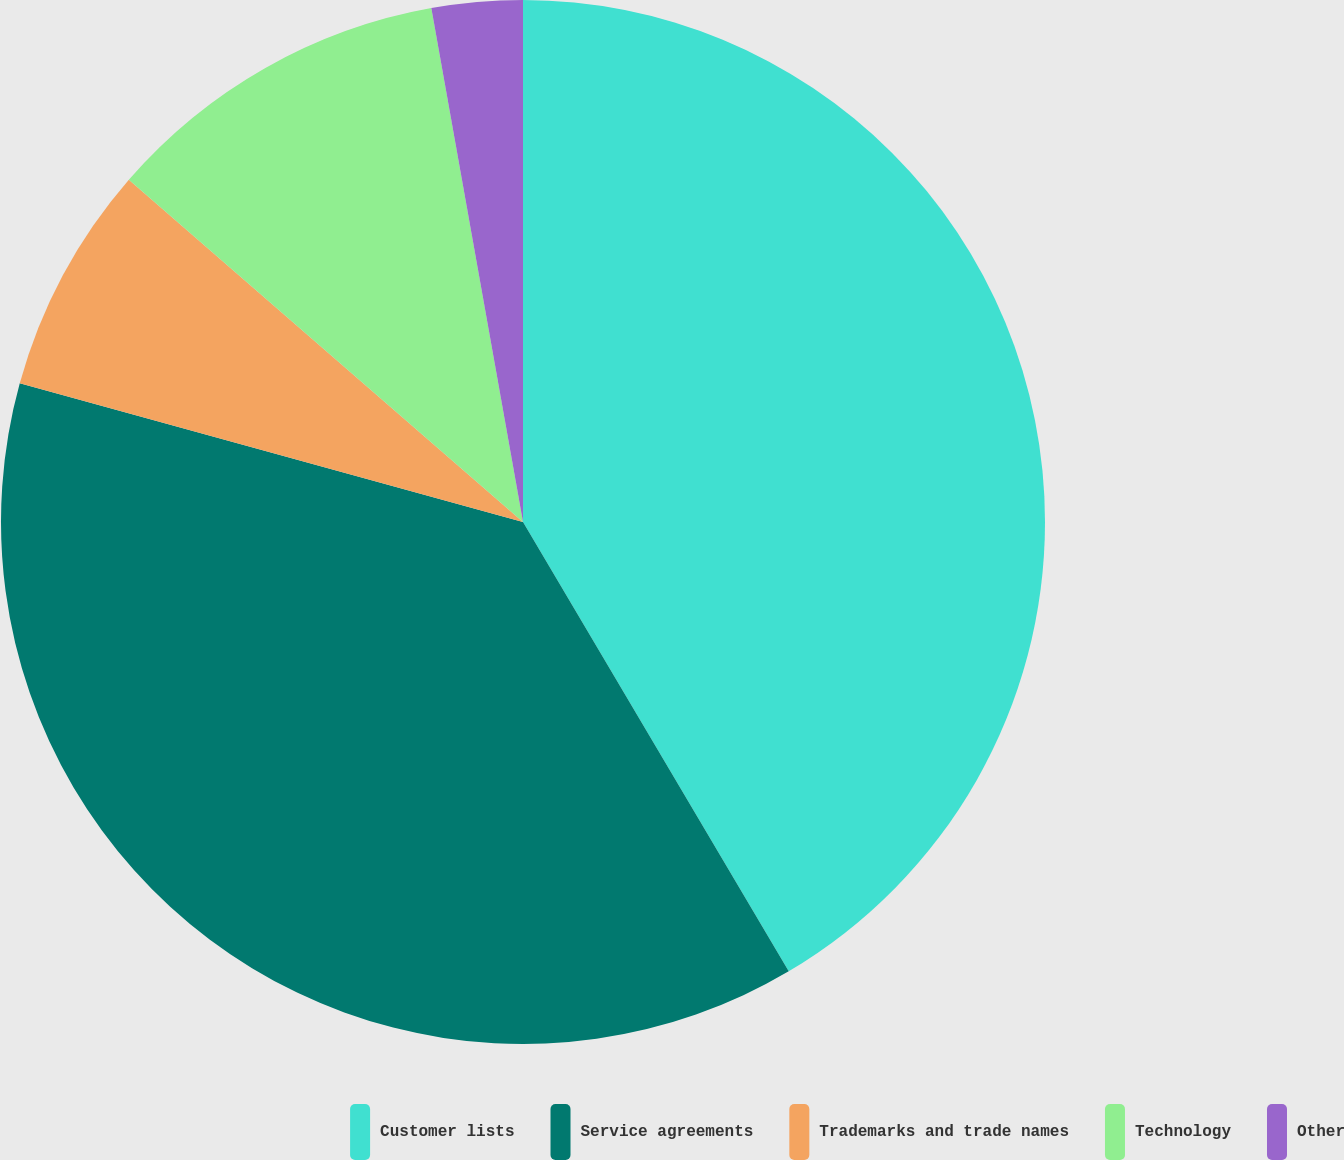Convert chart. <chart><loc_0><loc_0><loc_500><loc_500><pie_chart><fcel>Customer lists<fcel>Service agreements<fcel>Trademarks and trade names<fcel>Technology<fcel>Other<nl><fcel>41.5%<fcel>37.78%<fcel>7.1%<fcel>10.81%<fcel>2.81%<nl></chart> 